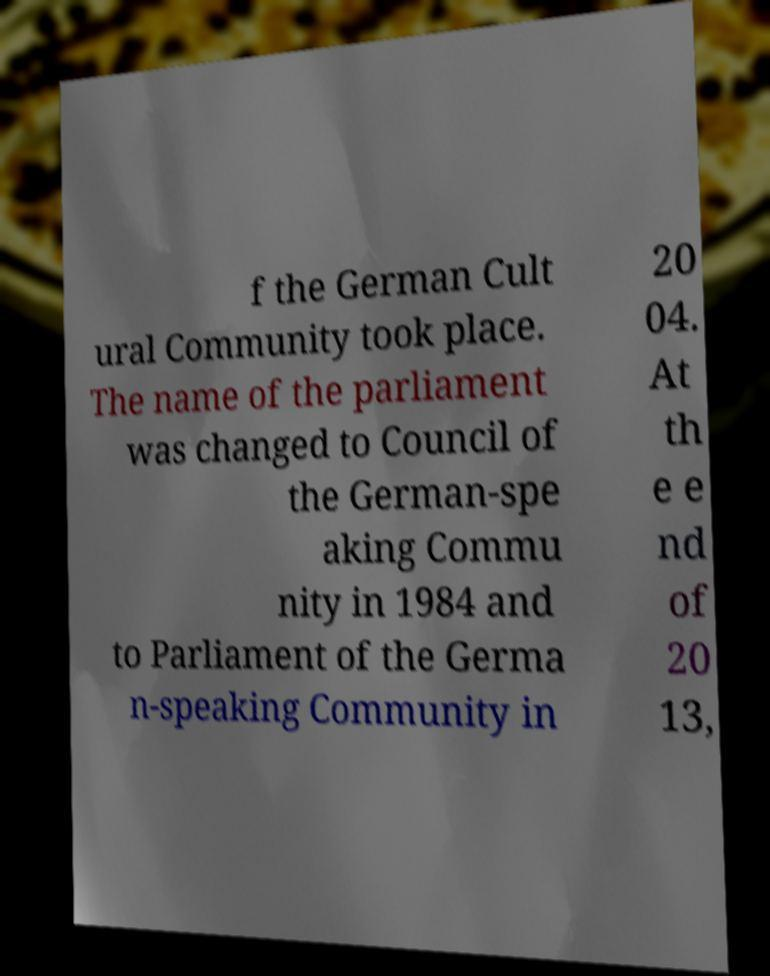I need the written content from this picture converted into text. Can you do that? f the German Cult ural Community took place. The name of the parliament was changed to Council of the German-spe aking Commu nity in 1984 and to Parliament of the Germa n-speaking Community in 20 04. At th e e nd of 20 13, 